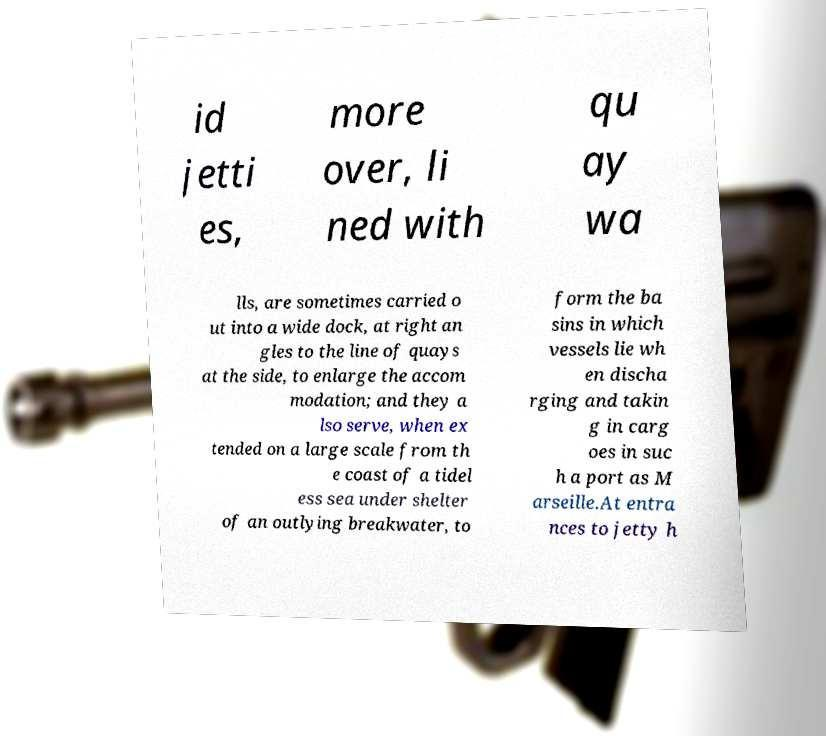Please read and relay the text visible in this image. What does it say? id jetti es, more over, li ned with qu ay wa lls, are sometimes carried o ut into a wide dock, at right an gles to the line of quays at the side, to enlarge the accom modation; and they a lso serve, when ex tended on a large scale from th e coast of a tidel ess sea under shelter of an outlying breakwater, to form the ba sins in which vessels lie wh en discha rging and takin g in carg oes in suc h a port as M arseille.At entra nces to jetty h 